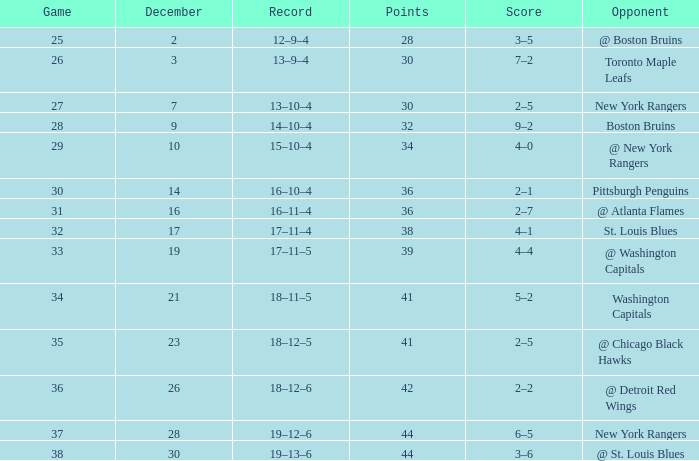Which Score has a Record of 18–11–5? 5–2. 